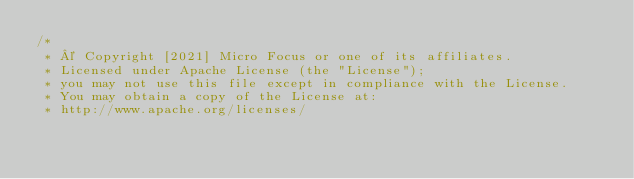<code> <loc_0><loc_0><loc_500><loc_500><_Java_>/*
 * © Copyright [2021] Micro Focus or one of its affiliates.
 * Licensed under Apache License (the "License");
 * you may not use this file except in compliance with the License.
 * You may obtain a copy of the License at:
 * http://www.apache.org/licenses/</code> 